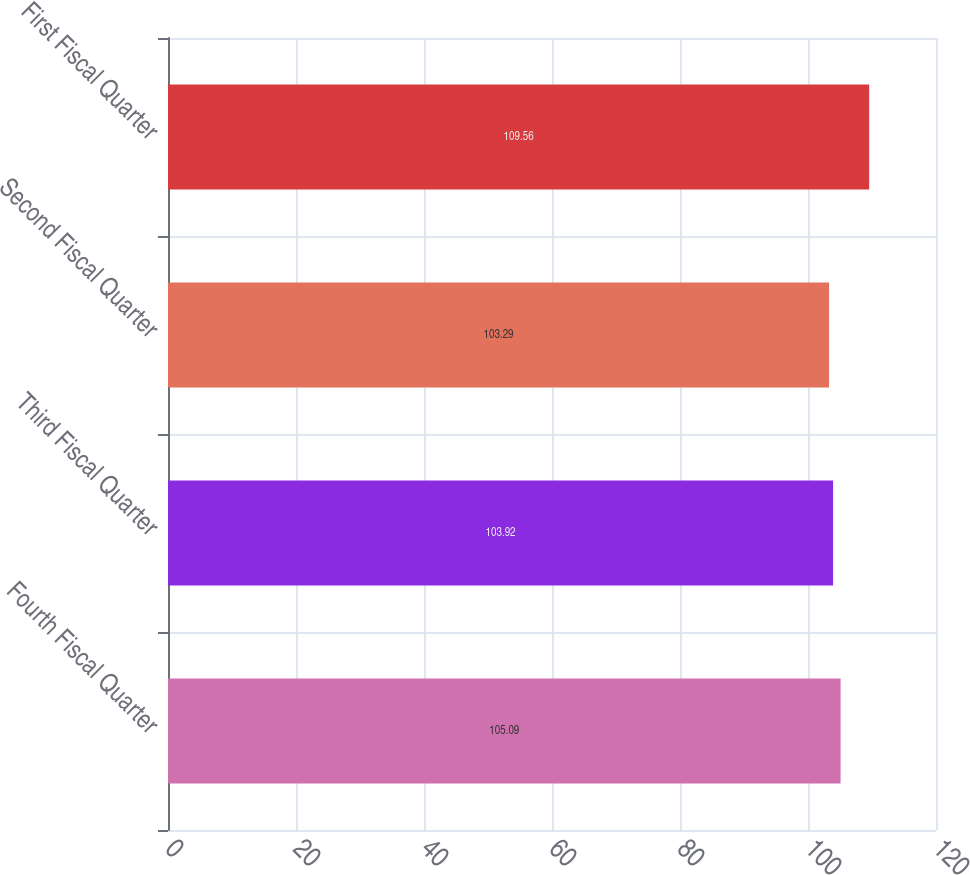<chart> <loc_0><loc_0><loc_500><loc_500><bar_chart><fcel>Fourth Fiscal Quarter<fcel>Third Fiscal Quarter<fcel>Second Fiscal Quarter<fcel>First Fiscal Quarter<nl><fcel>105.09<fcel>103.92<fcel>103.29<fcel>109.56<nl></chart> 